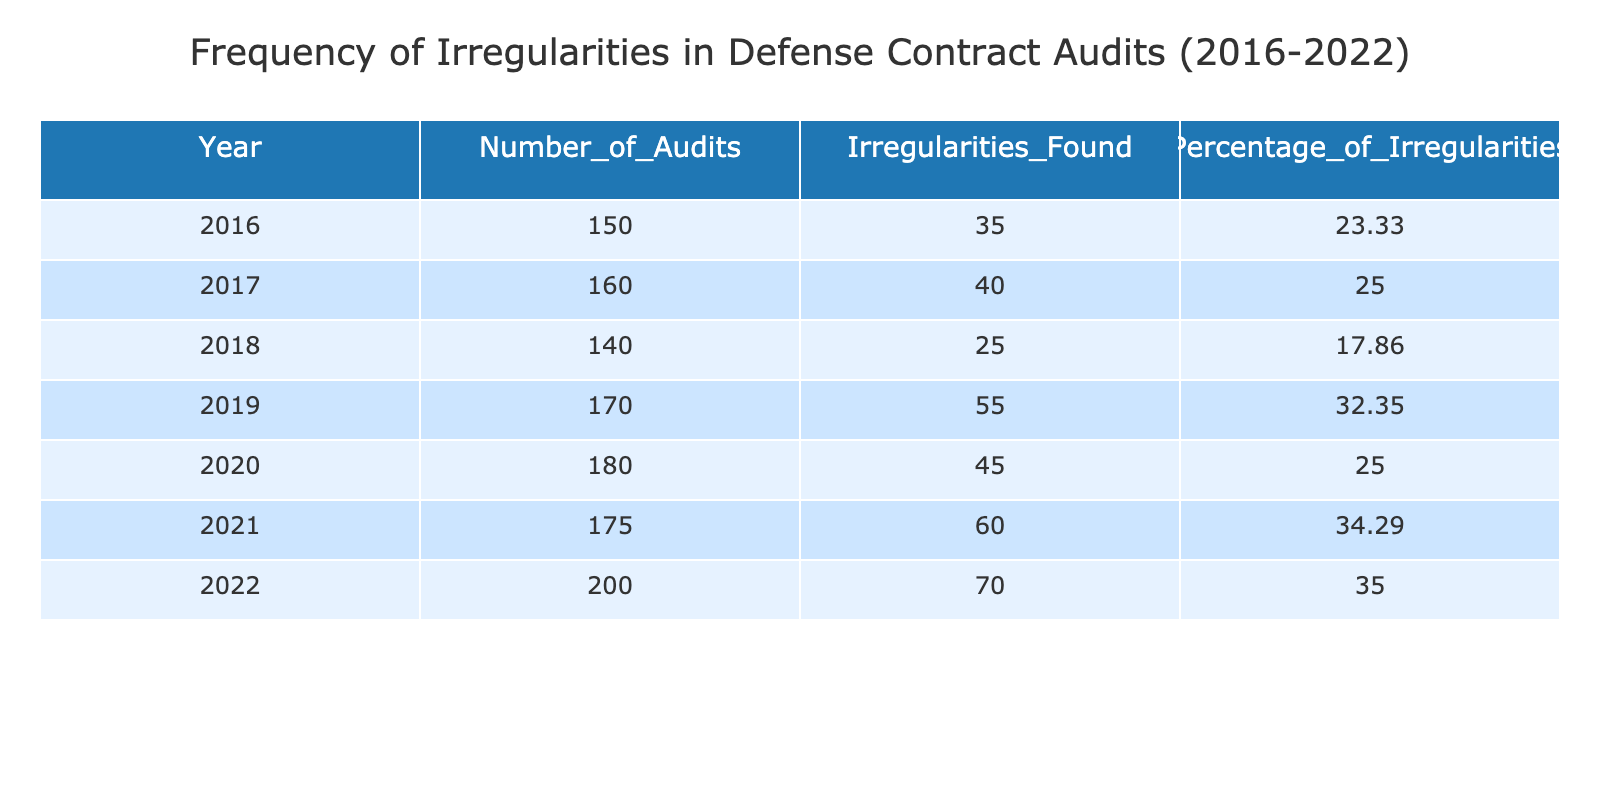What was the year with the highest percentage of irregularities found? Looking at the "Percentage of Irregularities" column, the highest value is 35.00, which corresponds to the year 2022.
Answer: 2022 How many irregularities were found in 2018? By checking the "Irregularities Found" column for the year 2018, the number is noted as 25.
Answer: 25 Which year had the least number of audits conducted, and how many were there? Reviewing the "Number of Audits" column, 2016 has the lowest value with 150 audits.
Answer: 2016, 150 What is the total number of irregularities found from 2016 to 2022? Summing up the irregularities for each year: 35 + 40 + 25 + 55 + 45 + 60 + 70 = 320.
Answer: 320 Is the statement "2020 had more irregularities than 2017" true or false? Looking at the irregularity counts, 2020 had 45 irregularities while 2017 had 40; hence the statement is true.
Answer: True What is the average percentage of irregularities found from 2016 to 2022? The percentages are: 23.33, 25.00, 17.86, 32.35, 25.00, 34.29, and 35.00. Adding these yields  23.33 + 25.00 + 17.86 + 32.35 + 25.00 + 34.29 + 35.00 = 193.83. Dividing by 7 gives an average of approximately 27.68.
Answer: 27.68 Which year showed the most significant increase in the number of irregularities compared to the previous year? Comparing the irregularities found year by year: 2019 (55) - 2018 (25) = 30, 2021 (60) - 2020 (45) = 15, and 2022 (70) - 2021 (60) = 10. The largest increase is 30 from 2018 to 2019.
Answer: 2019 In which year was the ratio of irregularities to audits the highest? To find the ratio, we divide the number of irregularities by the number of audits for each year. For instance, 2016: 35/150 = 0.2333, 2017: 40/160 = 0.25, 2018: 25/140 = 0.1786, and so forth. The highest ratio, 0.35, belongs to 2022.
Answer: 2022 Which year experienced a decrease in the number of irregularities compared to the previous year? Comparing each year, 2018 (25) to 2017 (40) is the only instance of a decrease.
Answer: 2018 